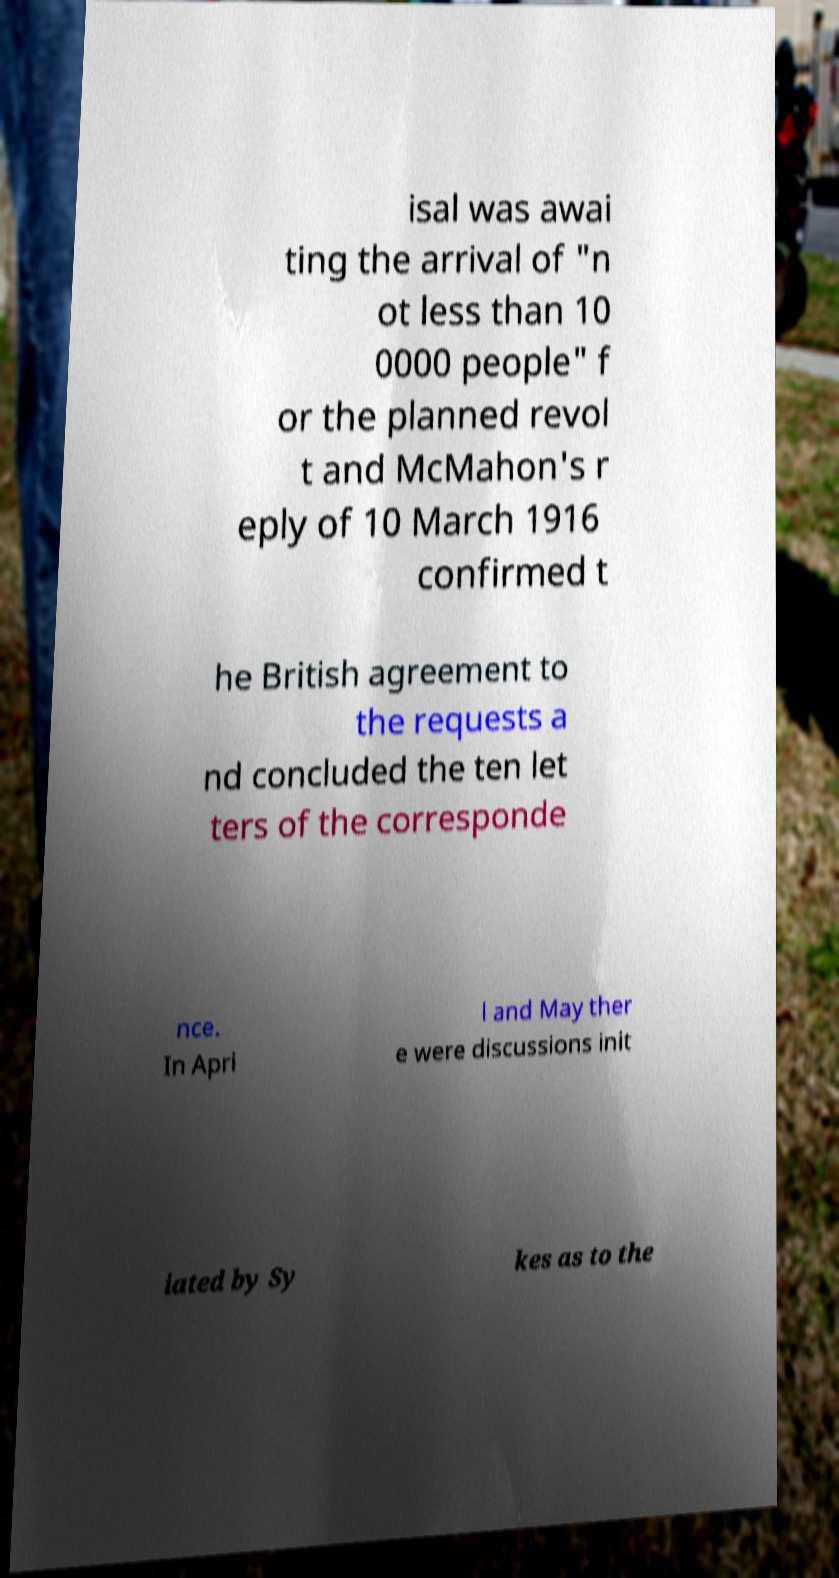For documentation purposes, I need the text within this image transcribed. Could you provide that? isal was awai ting the arrival of "n ot less than 10 0000 people" f or the planned revol t and McMahon's r eply of 10 March 1916 confirmed t he British agreement to the requests a nd concluded the ten let ters of the corresponde nce. In Apri l and May ther e were discussions init iated by Sy kes as to the 